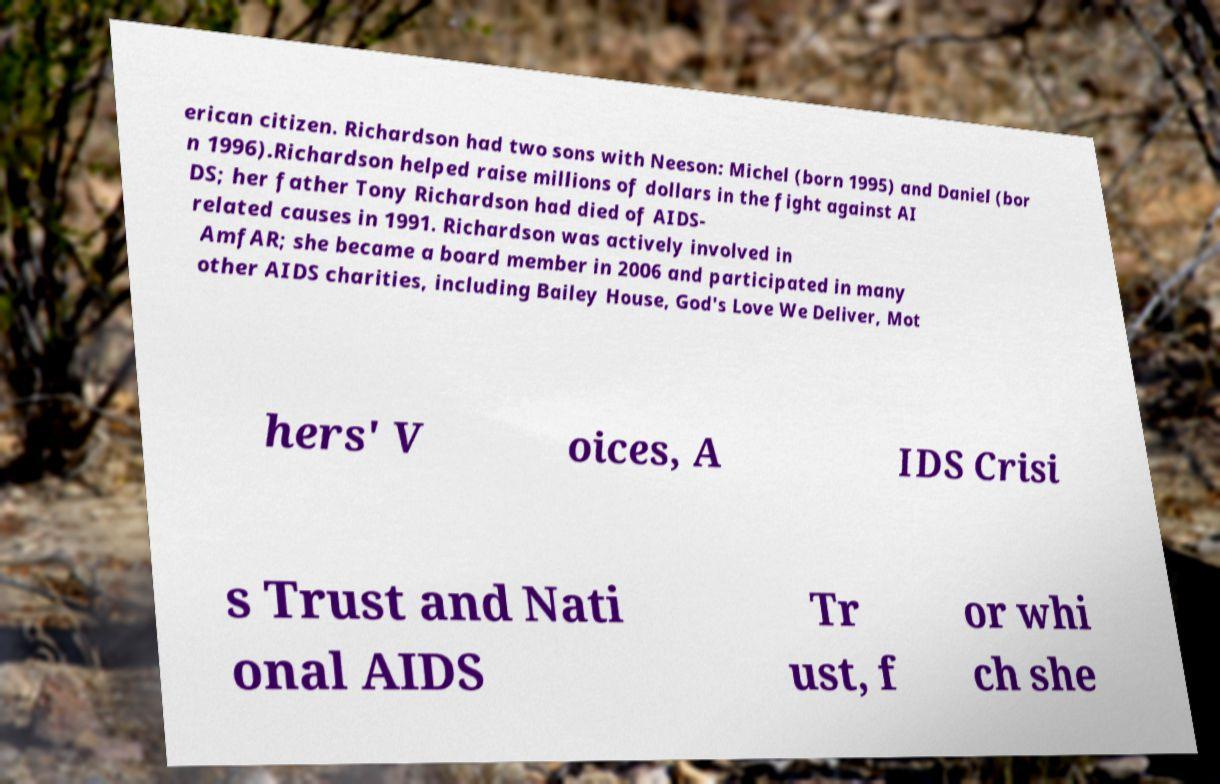For documentation purposes, I need the text within this image transcribed. Could you provide that? erican citizen. Richardson had two sons with Neeson: Michel (born 1995) and Daniel (bor n 1996).Richardson helped raise millions of dollars in the fight against AI DS; her father Tony Richardson had died of AIDS- related causes in 1991. Richardson was actively involved in AmfAR; she became a board member in 2006 and participated in many other AIDS charities, including Bailey House, God's Love We Deliver, Mot hers' V oices, A IDS Crisi s Trust and Nati onal AIDS Tr ust, f or whi ch she 